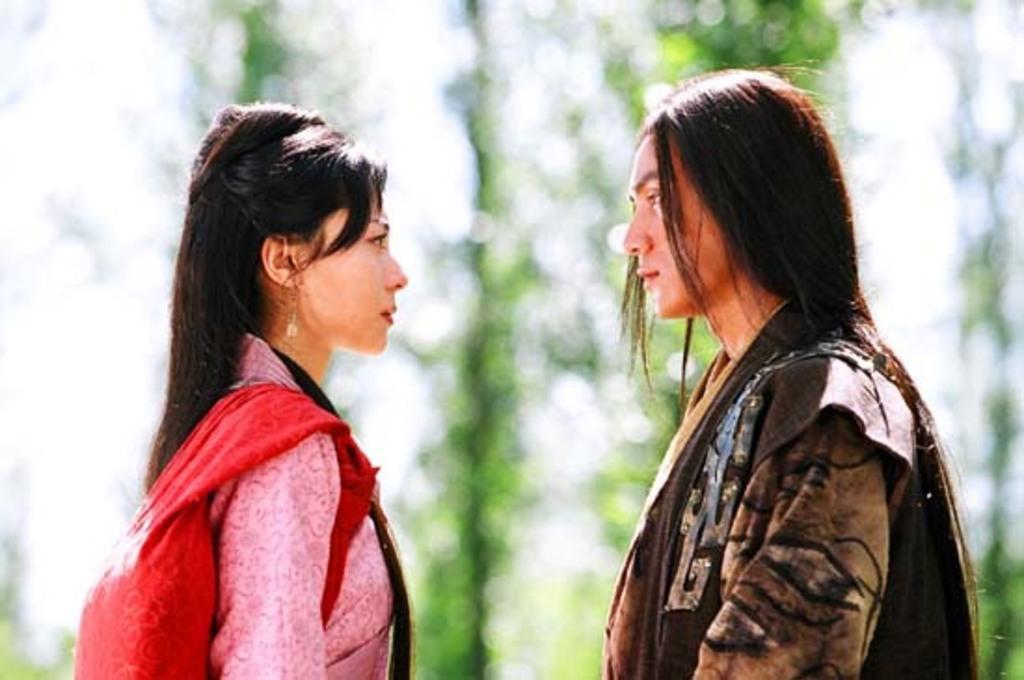Could you give a brief overview of what you see in this image? In this image we can see two persons with pink and brown color dresses and the background is blurry. 